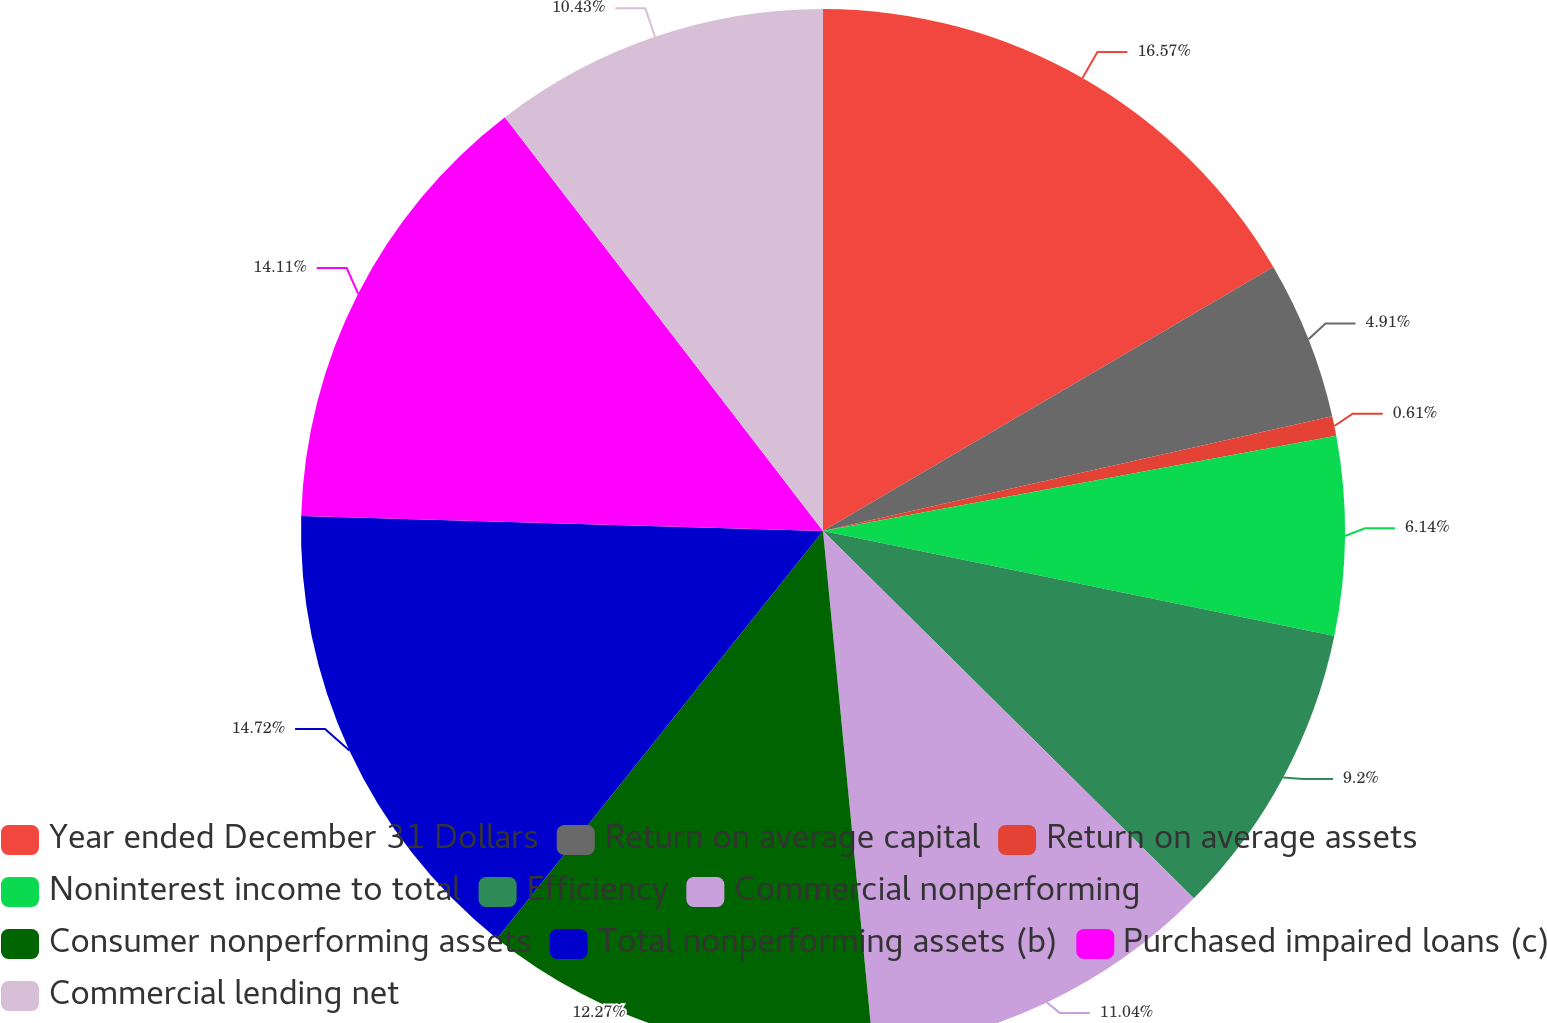Convert chart. <chart><loc_0><loc_0><loc_500><loc_500><pie_chart><fcel>Year ended December 31 Dollars<fcel>Return on average capital<fcel>Return on average assets<fcel>Noninterest income to total<fcel>Efficiency<fcel>Commercial nonperforming<fcel>Consumer nonperforming assets<fcel>Total nonperforming assets (b)<fcel>Purchased impaired loans (c)<fcel>Commercial lending net<nl><fcel>16.56%<fcel>4.91%<fcel>0.61%<fcel>6.14%<fcel>9.2%<fcel>11.04%<fcel>12.27%<fcel>14.72%<fcel>14.11%<fcel>10.43%<nl></chart> 